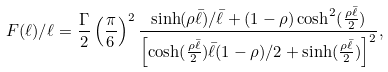<formula> <loc_0><loc_0><loc_500><loc_500>F ( \ell ) / \ell = \frac { \Gamma } { 2 } \left ( \frac { \pi } { 6 } \right ) ^ { 2 } \frac { \sinh ( \rho \bar { \ell } ) / \bar { \ell } + ( 1 - \rho ) \cosh ^ { 2 } ( \frac { \rho \bar { \ell } } { 2 } ) } { \left [ \cosh ( \frac { \rho \bar { \ell } } { 2 } ) \bar { \ell } ( 1 - \rho ) / 2 + \sinh ( \frac { \rho \bar { \ell } } { 2 } ) \right ] ^ { 2 } } ,</formula> 